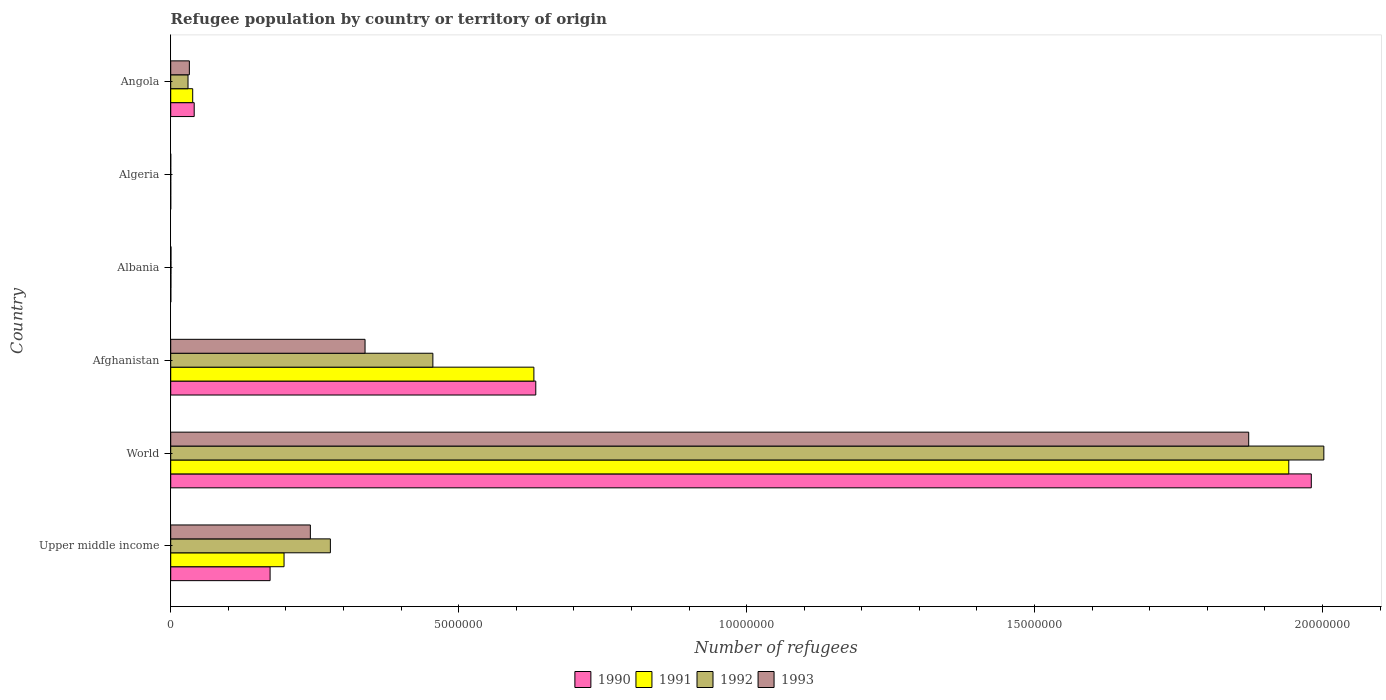How many groups of bars are there?
Give a very brief answer. 6. Are the number of bars on each tick of the Y-axis equal?
Provide a short and direct response. Yes. How many bars are there on the 4th tick from the top?
Keep it short and to the point. 4. How many bars are there on the 2nd tick from the bottom?
Your response must be concise. 4. What is the label of the 1st group of bars from the top?
Your response must be concise. Angola. What is the number of refugees in 1993 in Angola?
Ensure brevity in your answer.  3.24e+05. Across all countries, what is the maximum number of refugees in 1990?
Keep it short and to the point. 1.98e+07. Across all countries, what is the minimum number of refugees in 1992?
Your answer should be compact. 71. In which country was the number of refugees in 1992 maximum?
Provide a succinct answer. World. In which country was the number of refugees in 1993 minimum?
Make the answer very short. Algeria. What is the total number of refugees in 1992 in the graph?
Ensure brevity in your answer.  2.77e+07. What is the difference between the number of refugees in 1991 in Albania and that in World?
Keep it short and to the point. -1.94e+07. What is the difference between the number of refugees in 1990 in Albania and the number of refugees in 1992 in Angola?
Ensure brevity in your answer.  -2.99e+05. What is the average number of refugees in 1990 per country?
Offer a very short reply. 4.71e+06. What is the difference between the number of refugees in 1991 and number of refugees in 1993 in Albania?
Your answer should be compact. -1204. In how many countries, is the number of refugees in 1993 greater than 9000000 ?
Give a very brief answer. 1. What is the ratio of the number of refugees in 1993 in Albania to that in World?
Make the answer very short. 0. What is the difference between the highest and the second highest number of refugees in 1990?
Keep it short and to the point. 1.35e+07. What is the difference between the highest and the lowest number of refugees in 1991?
Ensure brevity in your answer.  1.94e+07. Is the sum of the number of refugees in 1991 in Algeria and Upper middle income greater than the maximum number of refugees in 1992 across all countries?
Keep it short and to the point. No. Is it the case that in every country, the sum of the number of refugees in 1991 and number of refugees in 1993 is greater than the sum of number of refugees in 1990 and number of refugees in 1992?
Provide a short and direct response. No. What does the 1st bar from the top in Upper middle income represents?
Give a very brief answer. 1993. What does the 4th bar from the bottom in Afghanistan represents?
Ensure brevity in your answer.  1993. How many bars are there?
Your response must be concise. 24. How many countries are there in the graph?
Keep it short and to the point. 6. What is the difference between two consecutive major ticks on the X-axis?
Provide a succinct answer. 5.00e+06. Are the values on the major ticks of X-axis written in scientific E-notation?
Give a very brief answer. No. Does the graph contain any zero values?
Ensure brevity in your answer.  No. Where does the legend appear in the graph?
Make the answer very short. Bottom center. How many legend labels are there?
Your answer should be very brief. 4. How are the legend labels stacked?
Offer a terse response. Horizontal. What is the title of the graph?
Provide a short and direct response. Refugee population by country or territory of origin. Does "2007" appear as one of the legend labels in the graph?
Your response must be concise. No. What is the label or title of the X-axis?
Ensure brevity in your answer.  Number of refugees. What is the Number of refugees in 1990 in Upper middle income?
Your answer should be compact. 1.73e+06. What is the Number of refugees in 1991 in Upper middle income?
Give a very brief answer. 1.97e+06. What is the Number of refugees of 1992 in Upper middle income?
Offer a terse response. 2.77e+06. What is the Number of refugees in 1993 in Upper middle income?
Give a very brief answer. 2.42e+06. What is the Number of refugees in 1990 in World?
Offer a very short reply. 1.98e+07. What is the Number of refugees of 1991 in World?
Provide a short and direct response. 1.94e+07. What is the Number of refugees of 1992 in World?
Make the answer very short. 2.00e+07. What is the Number of refugees of 1993 in World?
Make the answer very short. 1.87e+07. What is the Number of refugees in 1990 in Afghanistan?
Keep it short and to the point. 6.34e+06. What is the Number of refugees in 1991 in Afghanistan?
Provide a succinct answer. 6.31e+06. What is the Number of refugees of 1992 in Afghanistan?
Offer a very short reply. 4.55e+06. What is the Number of refugees of 1993 in Afghanistan?
Keep it short and to the point. 3.37e+06. What is the Number of refugees of 1990 in Albania?
Provide a succinct answer. 1822. What is the Number of refugees in 1991 in Albania?
Give a very brief answer. 3540. What is the Number of refugees of 1992 in Albania?
Make the answer very short. 4353. What is the Number of refugees of 1993 in Albania?
Your answer should be very brief. 4744. What is the Number of refugees of 1993 in Algeria?
Your response must be concise. 86. What is the Number of refugees in 1990 in Angola?
Keep it short and to the point. 4.08e+05. What is the Number of refugees of 1991 in Angola?
Make the answer very short. 3.82e+05. What is the Number of refugees of 1992 in Angola?
Provide a short and direct response. 3.00e+05. What is the Number of refugees in 1993 in Angola?
Your response must be concise. 3.24e+05. Across all countries, what is the maximum Number of refugees of 1990?
Your response must be concise. 1.98e+07. Across all countries, what is the maximum Number of refugees of 1991?
Ensure brevity in your answer.  1.94e+07. Across all countries, what is the maximum Number of refugees in 1992?
Keep it short and to the point. 2.00e+07. Across all countries, what is the maximum Number of refugees in 1993?
Your answer should be very brief. 1.87e+07. Across all countries, what is the minimum Number of refugees in 1992?
Offer a very short reply. 71. What is the total Number of refugees in 1990 in the graph?
Your answer should be very brief. 2.83e+07. What is the total Number of refugees of 1991 in the graph?
Provide a succinct answer. 2.81e+07. What is the total Number of refugees in 1992 in the graph?
Provide a short and direct response. 2.77e+07. What is the total Number of refugees of 1993 in the graph?
Provide a short and direct response. 2.48e+07. What is the difference between the Number of refugees of 1990 in Upper middle income and that in World?
Provide a short and direct response. -1.81e+07. What is the difference between the Number of refugees in 1991 in Upper middle income and that in World?
Keep it short and to the point. -1.74e+07. What is the difference between the Number of refugees of 1992 in Upper middle income and that in World?
Ensure brevity in your answer.  -1.73e+07. What is the difference between the Number of refugees in 1993 in Upper middle income and that in World?
Give a very brief answer. -1.63e+07. What is the difference between the Number of refugees in 1990 in Upper middle income and that in Afghanistan?
Give a very brief answer. -4.61e+06. What is the difference between the Number of refugees in 1991 in Upper middle income and that in Afghanistan?
Make the answer very short. -4.34e+06. What is the difference between the Number of refugees in 1992 in Upper middle income and that in Afghanistan?
Offer a terse response. -1.78e+06. What is the difference between the Number of refugees in 1993 in Upper middle income and that in Afghanistan?
Ensure brevity in your answer.  -9.50e+05. What is the difference between the Number of refugees in 1990 in Upper middle income and that in Albania?
Provide a short and direct response. 1.72e+06. What is the difference between the Number of refugees in 1991 in Upper middle income and that in Albania?
Your answer should be very brief. 1.96e+06. What is the difference between the Number of refugees in 1992 in Upper middle income and that in Albania?
Offer a very short reply. 2.77e+06. What is the difference between the Number of refugees in 1993 in Upper middle income and that in Albania?
Provide a short and direct response. 2.42e+06. What is the difference between the Number of refugees of 1990 in Upper middle income and that in Algeria?
Give a very brief answer. 1.73e+06. What is the difference between the Number of refugees in 1991 in Upper middle income and that in Algeria?
Your answer should be compact. 1.97e+06. What is the difference between the Number of refugees in 1992 in Upper middle income and that in Algeria?
Your answer should be very brief. 2.77e+06. What is the difference between the Number of refugees of 1993 in Upper middle income and that in Algeria?
Ensure brevity in your answer.  2.42e+06. What is the difference between the Number of refugees of 1990 in Upper middle income and that in Angola?
Keep it short and to the point. 1.32e+06. What is the difference between the Number of refugees in 1991 in Upper middle income and that in Angola?
Make the answer very short. 1.59e+06. What is the difference between the Number of refugees of 1992 in Upper middle income and that in Angola?
Your response must be concise. 2.47e+06. What is the difference between the Number of refugees of 1993 in Upper middle income and that in Angola?
Your response must be concise. 2.10e+06. What is the difference between the Number of refugees of 1990 in World and that in Afghanistan?
Keep it short and to the point. 1.35e+07. What is the difference between the Number of refugees of 1991 in World and that in Afghanistan?
Ensure brevity in your answer.  1.31e+07. What is the difference between the Number of refugees in 1992 in World and that in Afghanistan?
Your answer should be very brief. 1.55e+07. What is the difference between the Number of refugees of 1993 in World and that in Afghanistan?
Your answer should be very brief. 1.53e+07. What is the difference between the Number of refugees in 1990 in World and that in Albania?
Make the answer very short. 1.98e+07. What is the difference between the Number of refugees of 1991 in World and that in Albania?
Make the answer very short. 1.94e+07. What is the difference between the Number of refugees in 1992 in World and that in Albania?
Your answer should be compact. 2.00e+07. What is the difference between the Number of refugees in 1993 in World and that in Albania?
Provide a short and direct response. 1.87e+07. What is the difference between the Number of refugees of 1990 in World and that in Algeria?
Offer a very short reply. 1.98e+07. What is the difference between the Number of refugees in 1991 in World and that in Algeria?
Provide a short and direct response. 1.94e+07. What is the difference between the Number of refugees of 1992 in World and that in Algeria?
Give a very brief answer. 2.00e+07. What is the difference between the Number of refugees in 1993 in World and that in Algeria?
Give a very brief answer. 1.87e+07. What is the difference between the Number of refugees of 1990 in World and that in Angola?
Provide a succinct answer. 1.94e+07. What is the difference between the Number of refugees in 1991 in World and that in Angola?
Your answer should be very brief. 1.90e+07. What is the difference between the Number of refugees in 1992 in World and that in Angola?
Give a very brief answer. 1.97e+07. What is the difference between the Number of refugees in 1993 in World and that in Angola?
Offer a terse response. 1.84e+07. What is the difference between the Number of refugees in 1990 in Afghanistan and that in Albania?
Ensure brevity in your answer.  6.34e+06. What is the difference between the Number of refugees in 1991 in Afghanistan and that in Albania?
Your answer should be compact. 6.30e+06. What is the difference between the Number of refugees in 1992 in Afghanistan and that in Albania?
Your answer should be very brief. 4.55e+06. What is the difference between the Number of refugees in 1993 in Afghanistan and that in Albania?
Provide a short and direct response. 3.37e+06. What is the difference between the Number of refugees of 1990 in Afghanistan and that in Algeria?
Provide a short and direct response. 6.34e+06. What is the difference between the Number of refugees in 1991 in Afghanistan and that in Algeria?
Provide a short and direct response. 6.31e+06. What is the difference between the Number of refugees of 1992 in Afghanistan and that in Algeria?
Your answer should be very brief. 4.55e+06. What is the difference between the Number of refugees of 1993 in Afghanistan and that in Algeria?
Provide a succinct answer. 3.37e+06. What is the difference between the Number of refugees in 1990 in Afghanistan and that in Angola?
Provide a succinct answer. 5.93e+06. What is the difference between the Number of refugees in 1991 in Afghanistan and that in Angola?
Offer a terse response. 5.92e+06. What is the difference between the Number of refugees in 1992 in Afghanistan and that in Angola?
Offer a terse response. 4.25e+06. What is the difference between the Number of refugees of 1993 in Afghanistan and that in Angola?
Provide a short and direct response. 3.05e+06. What is the difference between the Number of refugees of 1990 in Albania and that in Algeria?
Offer a very short reply. 1803. What is the difference between the Number of refugees of 1991 in Albania and that in Algeria?
Your answer should be very brief. 3485. What is the difference between the Number of refugees in 1992 in Albania and that in Algeria?
Ensure brevity in your answer.  4282. What is the difference between the Number of refugees in 1993 in Albania and that in Algeria?
Keep it short and to the point. 4658. What is the difference between the Number of refugees of 1990 in Albania and that in Angola?
Ensure brevity in your answer.  -4.06e+05. What is the difference between the Number of refugees of 1991 in Albania and that in Angola?
Make the answer very short. -3.78e+05. What is the difference between the Number of refugees of 1992 in Albania and that in Angola?
Make the answer very short. -2.96e+05. What is the difference between the Number of refugees of 1993 in Albania and that in Angola?
Ensure brevity in your answer.  -3.19e+05. What is the difference between the Number of refugees of 1990 in Algeria and that in Angola?
Offer a terse response. -4.08e+05. What is the difference between the Number of refugees in 1991 in Algeria and that in Angola?
Your answer should be very brief. -3.82e+05. What is the difference between the Number of refugees of 1992 in Algeria and that in Angola?
Provide a succinct answer. -3.00e+05. What is the difference between the Number of refugees of 1993 in Algeria and that in Angola?
Provide a short and direct response. -3.24e+05. What is the difference between the Number of refugees of 1990 in Upper middle income and the Number of refugees of 1991 in World?
Your answer should be very brief. -1.77e+07. What is the difference between the Number of refugees of 1990 in Upper middle income and the Number of refugees of 1992 in World?
Offer a terse response. -1.83e+07. What is the difference between the Number of refugees in 1990 in Upper middle income and the Number of refugees in 1993 in World?
Provide a short and direct response. -1.70e+07. What is the difference between the Number of refugees of 1991 in Upper middle income and the Number of refugees of 1992 in World?
Provide a short and direct response. -1.81e+07. What is the difference between the Number of refugees of 1991 in Upper middle income and the Number of refugees of 1993 in World?
Your response must be concise. -1.68e+07. What is the difference between the Number of refugees in 1992 in Upper middle income and the Number of refugees in 1993 in World?
Ensure brevity in your answer.  -1.59e+07. What is the difference between the Number of refugees of 1990 in Upper middle income and the Number of refugees of 1991 in Afghanistan?
Ensure brevity in your answer.  -4.58e+06. What is the difference between the Number of refugees of 1990 in Upper middle income and the Number of refugees of 1992 in Afghanistan?
Give a very brief answer. -2.83e+06. What is the difference between the Number of refugees in 1990 in Upper middle income and the Number of refugees in 1993 in Afghanistan?
Offer a terse response. -1.65e+06. What is the difference between the Number of refugees of 1991 in Upper middle income and the Number of refugees of 1992 in Afghanistan?
Make the answer very short. -2.58e+06. What is the difference between the Number of refugees of 1991 in Upper middle income and the Number of refugees of 1993 in Afghanistan?
Offer a terse response. -1.41e+06. What is the difference between the Number of refugees of 1992 in Upper middle income and the Number of refugees of 1993 in Afghanistan?
Ensure brevity in your answer.  -6.02e+05. What is the difference between the Number of refugees of 1990 in Upper middle income and the Number of refugees of 1991 in Albania?
Keep it short and to the point. 1.72e+06. What is the difference between the Number of refugees of 1990 in Upper middle income and the Number of refugees of 1992 in Albania?
Provide a succinct answer. 1.72e+06. What is the difference between the Number of refugees of 1990 in Upper middle income and the Number of refugees of 1993 in Albania?
Your answer should be compact. 1.72e+06. What is the difference between the Number of refugees in 1991 in Upper middle income and the Number of refugees in 1992 in Albania?
Provide a succinct answer. 1.96e+06. What is the difference between the Number of refugees of 1991 in Upper middle income and the Number of refugees of 1993 in Albania?
Make the answer very short. 1.96e+06. What is the difference between the Number of refugees in 1992 in Upper middle income and the Number of refugees in 1993 in Albania?
Keep it short and to the point. 2.77e+06. What is the difference between the Number of refugees in 1990 in Upper middle income and the Number of refugees in 1991 in Algeria?
Your answer should be very brief. 1.73e+06. What is the difference between the Number of refugees in 1990 in Upper middle income and the Number of refugees in 1992 in Algeria?
Your answer should be very brief. 1.73e+06. What is the difference between the Number of refugees of 1990 in Upper middle income and the Number of refugees of 1993 in Algeria?
Make the answer very short. 1.73e+06. What is the difference between the Number of refugees of 1991 in Upper middle income and the Number of refugees of 1992 in Algeria?
Provide a short and direct response. 1.97e+06. What is the difference between the Number of refugees of 1991 in Upper middle income and the Number of refugees of 1993 in Algeria?
Provide a succinct answer. 1.97e+06. What is the difference between the Number of refugees in 1992 in Upper middle income and the Number of refugees in 1993 in Algeria?
Provide a succinct answer. 2.77e+06. What is the difference between the Number of refugees in 1990 in Upper middle income and the Number of refugees in 1991 in Angola?
Offer a terse response. 1.34e+06. What is the difference between the Number of refugees in 1990 in Upper middle income and the Number of refugees in 1992 in Angola?
Your answer should be compact. 1.43e+06. What is the difference between the Number of refugees in 1990 in Upper middle income and the Number of refugees in 1993 in Angola?
Your answer should be very brief. 1.40e+06. What is the difference between the Number of refugees of 1991 in Upper middle income and the Number of refugees of 1992 in Angola?
Provide a succinct answer. 1.67e+06. What is the difference between the Number of refugees in 1991 in Upper middle income and the Number of refugees in 1993 in Angola?
Give a very brief answer. 1.64e+06. What is the difference between the Number of refugees of 1992 in Upper middle income and the Number of refugees of 1993 in Angola?
Offer a very short reply. 2.45e+06. What is the difference between the Number of refugees of 1990 in World and the Number of refugees of 1991 in Afghanistan?
Provide a short and direct response. 1.35e+07. What is the difference between the Number of refugees of 1990 in World and the Number of refugees of 1992 in Afghanistan?
Give a very brief answer. 1.53e+07. What is the difference between the Number of refugees of 1990 in World and the Number of refugees of 1993 in Afghanistan?
Your response must be concise. 1.64e+07. What is the difference between the Number of refugees of 1991 in World and the Number of refugees of 1992 in Afghanistan?
Your answer should be compact. 1.49e+07. What is the difference between the Number of refugees in 1991 in World and the Number of refugees in 1993 in Afghanistan?
Ensure brevity in your answer.  1.60e+07. What is the difference between the Number of refugees of 1992 in World and the Number of refugees of 1993 in Afghanistan?
Keep it short and to the point. 1.66e+07. What is the difference between the Number of refugees in 1990 in World and the Number of refugees in 1991 in Albania?
Provide a succinct answer. 1.98e+07. What is the difference between the Number of refugees in 1990 in World and the Number of refugees in 1992 in Albania?
Your answer should be compact. 1.98e+07. What is the difference between the Number of refugees in 1990 in World and the Number of refugees in 1993 in Albania?
Ensure brevity in your answer.  1.98e+07. What is the difference between the Number of refugees in 1991 in World and the Number of refugees in 1992 in Albania?
Offer a very short reply. 1.94e+07. What is the difference between the Number of refugees of 1991 in World and the Number of refugees of 1993 in Albania?
Provide a succinct answer. 1.94e+07. What is the difference between the Number of refugees of 1992 in World and the Number of refugees of 1993 in Albania?
Your answer should be compact. 2.00e+07. What is the difference between the Number of refugees of 1990 in World and the Number of refugees of 1991 in Algeria?
Keep it short and to the point. 1.98e+07. What is the difference between the Number of refugees in 1990 in World and the Number of refugees in 1992 in Algeria?
Provide a short and direct response. 1.98e+07. What is the difference between the Number of refugees of 1990 in World and the Number of refugees of 1993 in Algeria?
Provide a succinct answer. 1.98e+07. What is the difference between the Number of refugees of 1991 in World and the Number of refugees of 1992 in Algeria?
Keep it short and to the point. 1.94e+07. What is the difference between the Number of refugees of 1991 in World and the Number of refugees of 1993 in Algeria?
Your response must be concise. 1.94e+07. What is the difference between the Number of refugees of 1992 in World and the Number of refugees of 1993 in Algeria?
Provide a short and direct response. 2.00e+07. What is the difference between the Number of refugees of 1990 in World and the Number of refugees of 1991 in Angola?
Your answer should be compact. 1.94e+07. What is the difference between the Number of refugees in 1990 in World and the Number of refugees in 1992 in Angola?
Your answer should be compact. 1.95e+07. What is the difference between the Number of refugees of 1990 in World and the Number of refugees of 1993 in Angola?
Your answer should be compact. 1.95e+07. What is the difference between the Number of refugees in 1991 in World and the Number of refugees in 1992 in Angola?
Your answer should be compact. 1.91e+07. What is the difference between the Number of refugees of 1991 in World and the Number of refugees of 1993 in Angola?
Give a very brief answer. 1.91e+07. What is the difference between the Number of refugees of 1992 in World and the Number of refugees of 1993 in Angola?
Ensure brevity in your answer.  1.97e+07. What is the difference between the Number of refugees in 1990 in Afghanistan and the Number of refugees in 1991 in Albania?
Ensure brevity in your answer.  6.34e+06. What is the difference between the Number of refugees of 1990 in Afghanistan and the Number of refugees of 1992 in Albania?
Keep it short and to the point. 6.33e+06. What is the difference between the Number of refugees in 1990 in Afghanistan and the Number of refugees in 1993 in Albania?
Offer a terse response. 6.33e+06. What is the difference between the Number of refugees of 1991 in Afghanistan and the Number of refugees of 1992 in Albania?
Your answer should be compact. 6.30e+06. What is the difference between the Number of refugees in 1991 in Afghanistan and the Number of refugees in 1993 in Albania?
Give a very brief answer. 6.30e+06. What is the difference between the Number of refugees of 1992 in Afghanistan and the Number of refugees of 1993 in Albania?
Your answer should be compact. 4.55e+06. What is the difference between the Number of refugees in 1990 in Afghanistan and the Number of refugees in 1991 in Algeria?
Provide a short and direct response. 6.34e+06. What is the difference between the Number of refugees in 1990 in Afghanistan and the Number of refugees in 1992 in Algeria?
Offer a terse response. 6.34e+06. What is the difference between the Number of refugees of 1990 in Afghanistan and the Number of refugees of 1993 in Algeria?
Keep it short and to the point. 6.34e+06. What is the difference between the Number of refugees in 1991 in Afghanistan and the Number of refugees in 1992 in Algeria?
Ensure brevity in your answer.  6.31e+06. What is the difference between the Number of refugees in 1991 in Afghanistan and the Number of refugees in 1993 in Algeria?
Ensure brevity in your answer.  6.31e+06. What is the difference between the Number of refugees in 1992 in Afghanistan and the Number of refugees in 1993 in Algeria?
Provide a succinct answer. 4.55e+06. What is the difference between the Number of refugees of 1990 in Afghanistan and the Number of refugees of 1991 in Angola?
Offer a very short reply. 5.96e+06. What is the difference between the Number of refugees in 1990 in Afghanistan and the Number of refugees in 1992 in Angola?
Provide a short and direct response. 6.04e+06. What is the difference between the Number of refugees of 1990 in Afghanistan and the Number of refugees of 1993 in Angola?
Your answer should be very brief. 6.02e+06. What is the difference between the Number of refugees of 1991 in Afghanistan and the Number of refugees of 1992 in Angola?
Give a very brief answer. 6.01e+06. What is the difference between the Number of refugees of 1991 in Afghanistan and the Number of refugees of 1993 in Angola?
Offer a terse response. 5.98e+06. What is the difference between the Number of refugees of 1992 in Afghanistan and the Number of refugees of 1993 in Angola?
Your answer should be very brief. 4.23e+06. What is the difference between the Number of refugees of 1990 in Albania and the Number of refugees of 1991 in Algeria?
Keep it short and to the point. 1767. What is the difference between the Number of refugees in 1990 in Albania and the Number of refugees in 1992 in Algeria?
Provide a short and direct response. 1751. What is the difference between the Number of refugees in 1990 in Albania and the Number of refugees in 1993 in Algeria?
Give a very brief answer. 1736. What is the difference between the Number of refugees of 1991 in Albania and the Number of refugees of 1992 in Algeria?
Provide a short and direct response. 3469. What is the difference between the Number of refugees in 1991 in Albania and the Number of refugees in 1993 in Algeria?
Your answer should be very brief. 3454. What is the difference between the Number of refugees of 1992 in Albania and the Number of refugees of 1993 in Algeria?
Your answer should be very brief. 4267. What is the difference between the Number of refugees of 1990 in Albania and the Number of refugees of 1991 in Angola?
Provide a short and direct response. -3.80e+05. What is the difference between the Number of refugees in 1990 in Albania and the Number of refugees in 1992 in Angola?
Give a very brief answer. -2.99e+05. What is the difference between the Number of refugees of 1990 in Albania and the Number of refugees of 1993 in Angola?
Offer a terse response. -3.22e+05. What is the difference between the Number of refugees of 1991 in Albania and the Number of refugees of 1992 in Angola?
Ensure brevity in your answer.  -2.97e+05. What is the difference between the Number of refugees in 1991 in Albania and the Number of refugees in 1993 in Angola?
Make the answer very short. -3.20e+05. What is the difference between the Number of refugees in 1992 in Albania and the Number of refugees in 1993 in Angola?
Your response must be concise. -3.19e+05. What is the difference between the Number of refugees in 1990 in Algeria and the Number of refugees in 1991 in Angola?
Your answer should be compact. -3.82e+05. What is the difference between the Number of refugees of 1990 in Algeria and the Number of refugees of 1992 in Angola?
Your answer should be compact. -3.00e+05. What is the difference between the Number of refugees in 1990 in Algeria and the Number of refugees in 1993 in Angola?
Your answer should be very brief. -3.24e+05. What is the difference between the Number of refugees of 1991 in Algeria and the Number of refugees of 1992 in Angola?
Make the answer very short. -3.00e+05. What is the difference between the Number of refugees of 1991 in Algeria and the Number of refugees of 1993 in Angola?
Offer a terse response. -3.24e+05. What is the difference between the Number of refugees in 1992 in Algeria and the Number of refugees in 1993 in Angola?
Your response must be concise. -3.24e+05. What is the average Number of refugees in 1990 per country?
Offer a terse response. 4.71e+06. What is the average Number of refugees in 1991 per country?
Provide a succinct answer. 4.68e+06. What is the average Number of refugees of 1992 per country?
Your answer should be very brief. 4.61e+06. What is the average Number of refugees in 1993 per country?
Ensure brevity in your answer.  4.14e+06. What is the difference between the Number of refugees of 1990 and Number of refugees of 1991 in Upper middle income?
Your response must be concise. -2.42e+05. What is the difference between the Number of refugees in 1990 and Number of refugees in 1992 in Upper middle income?
Your answer should be very brief. -1.05e+06. What is the difference between the Number of refugees of 1990 and Number of refugees of 1993 in Upper middle income?
Make the answer very short. -6.99e+05. What is the difference between the Number of refugees of 1991 and Number of refugees of 1992 in Upper middle income?
Your answer should be compact. -8.04e+05. What is the difference between the Number of refugees in 1991 and Number of refugees in 1993 in Upper middle income?
Offer a very short reply. -4.57e+05. What is the difference between the Number of refugees in 1992 and Number of refugees in 1993 in Upper middle income?
Give a very brief answer. 3.48e+05. What is the difference between the Number of refugees of 1990 and Number of refugees of 1991 in World?
Keep it short and to the point. 3.91e+05. What is the difference between the Number of refugees of 1990 and Number of refugees of 1992 in World?
Provide a succinct answer. -2.18e+05. What is the difference between the Number of refugees of 1990 and Number of refugees of 1993 in World?
Provide a short and direct response. 1.09e+06. What is the difference between the Number of refugees of 1991 and Number of refugees of 1992 in World?
Your response must be concise. -6.09e+05. What is the difference between the Number of refugees of 1991 and Number of refugees of 1993 in World?
Offer a very short reply. 6.96e+05. What is the difference between the Number of refugees in 1992 and Number of refugees in 1993 in World?
Your answer should be compact. 1.30e+06. What is the difference between the Number of refugees in 1990 and Number of refugees in 1991 in Afghanistan?
Your answer should be compact. 3.28e+04. What is the difference between the Number of refugees in 1990 and Number of refugees in 1992 in Afghanistan?
Keep it short and to the point. 1.79e+06. What is the difference between the Number of refugees of 1990 and Number of refugees of 1993 in Afghanistan?
Give a very brief answer. 2.96e+06. What is the difference between the Number of refugees of 1991 and Number of refugees of 1992 in Afghanistan?
Ensure brevity in your answer.  1.75e+06. What is the difference between the Number of refugees of 1991 and Number of refugees of 1993 in Afghanistan?
Provide a short and direct response. 2.93e+06. What is the difference between the Number of refugees in 1992 and Number of refugees in 1993 in Afghanistan?
Provide a short and direct response. 1.18e+06. What is the difference between the Number of refugees of 1990 and Number of refugees of 1991 in Albania?
Provide a short and direct response. -1718. What is the difference between the Number of refugees in 1990 and Number of refugees in 1992 in Albania?
Ensure brevity in your answer.  -2531. What is the difference between the Number of refugees of 1990 and Number of refugees of 1993 in Albania?
Ensure brevity in your answer.  -2922. What is the difference between the Number of refugees of 1991 and Number of refugees of 1992 in Albania?
Make the answer very short. -813. What is the difference between the Number of refugees of 1991 and Number of refugees of 1993 in Albania?
Make the answer very short. -1204. What is the difference between the Number of refugees in 1992 and Number of refugees in 1993 in Albania?
Provide a succinct answer. -391. What is the difference between the Number of refugees in 1990 and Number of refugees in 1991 in Algeria?
Offer a very short reply. -36. What is the difference between the Number of refugees of 1990 and Number of refugees of 1992 in Algeria?
Your response must be concise. -52. What is the difference between the Number of refugees in 1990 and Number of refugees in 1993 in Algeria?
Your answer should be very brief. -67. What is the difference between the Number of refugees of 1991 and Number of refugees of 1993 in Algeria?
Your answer should be very brief. -31. What is the difference between the Number of refugees of 1992 and Number of refugees of 1993 in Algeria?
Your answer should be compact. -15. What is the difference between the Number of refugees of 1990 and Number of refugees of 1991 in Angola?
Provide a succinct answer. 2.61e+04. What is the difference between the Number of refugees in 1990 and Number of refugees in 1992 in Angola?
Give a very brief answer. 1.07e+05. What is the difference between the Number of refugees in 1990 and Number of refugees in 1993 in Angola?
Ensure brevity in your answer.  8.39e+04. What is the difference between the Number of refugees in 1991 and Number of refugees in 1992 in Angola?
Make the answer very short. 8.11e+04. What is the difference between the Number of refugees of 1991 and Number of refugees of 1993 in Angola?
Offer a terse response. 5.78e+04. What is the difference between the Number of refugees in 1992 and Number of refugees in 1993 in Angola?
Offer a terse response. -2.33e+04. What is the ratio of the Number of refugees of 1990 in Upper middle income to that in World?
Keep it short and to the point. 0.09. What is the ratio of the Number of refugees of 1991 in Upper middle income to that in World?
Make the answer very short. 0.1. What is the ratio of the Number of refugees of 1992 in Upper middle income to that in World?
Provide a succinct answer. 0.14. What is the ratio of the Number of refugees of 1993 in Upper middle income to that in World?
Offer a terse response. 0.13. What is the ratio of the Number of refugees of 1990 in Upper middle income to that in Afghanistan?
Keep it short and to the point. 0.27. What is the ratio of the Number of refugees in 1991 in Upper middle income to that in Afghanistan?
Give a very brief answer. 0.31. What is the ratio of the Number of refugees in 1992 in Upper middle income to that in Afghanistan?
Ensure brevity in your answer.  0.61. What is the ratio of the Number of refugees of 1993 in Upper middle income to that in Afghanistan?
Offer a very short reply. 0.72. What is the ratio of the Number of refugees in 1990 in Upper middle income to that in Albania?
Keep it short and to the point. 947.17. What is the ratio of the Number of refugees of 1991 in Upper middle income to that in Albania?
Offer a terse response. 555.95. What is the ratio of the Number of refugees of 1992 in Upper middle income to that in Albania?
Offer a very short reply. 636.92. What is the ratio of the Number of refugees of 1993 in Upper middle income to that in Albania?
Provide a succinct answer. 511.15. What is the ratio of the Number of refugees of 1990 in Upper middle income to that in Algeria?
Give a very brief answer. 9.08e+04. What is the ratio of the Number of refugees in 1991 in Upper middle income to that in Algeria?
Offer a very short reply. 3.58e+04. What is the ratio of the Number of refugees of 1992 in Upper middle income to that in Algeria?
Your response must be concise. 3.90e+04. What is the ratio of the Number of refugees of 1993 in Upper middle income to that in Algeria?
Keep it short and to the point. 2.82e+04. What is the ratio of the Number of refugees in 1990 in Upper middle income to that in Angola?
Ensure brevity in your answer.  4.23. What is the ratio of the Number of refugees in 1991 in Upper middle income to that in Angola?
Provide a short and direct response. 5.16. What is the ratio of the Number of refugees in 1992 in Upper middle income to that in Angola?
Your response must be concise. 9.23. What is the ratio of the Number of refugees in 1993 in Upper middle income to that in Angola?
Give a very brief answer. 7.49. What is the ratio of the Number of refugees in 1990 in World to that in Afghanistan?
Your answer should be very brief. 3.12. What is the ratio of the Number of refugees of 1991 in World to that in Afghanistan?
Your response must be concise. 3.08. What is the ratio of the Number of refugees in 1992 in World to that in Afghanistan?
Offer a terse response. 4.4. What is the ratio of the Number of refugees in 1993 in World to that in Afghanistan?
Ensure brevity in your answer.  5.55. What is the ratio of the Number of refugees of 1990 in World to that in Albania?
Offer a terse response. 1.09e+04. What is the ratio of the Number of refugees of 1991 in World to that in Albania?
Ensure brevity in your answer.  5484.44. What is the ratio of the Number of refugees of 1992 in World to that in Albania?
Offer a very short reply. 4599.94. What is the ratio of the Number of refugees of 1993 in World to that in Albania?
Keep it short and to the point. 3945.82. What is the ratio of the Number of refugees of 1990 in World to that in Algeria?
Keep it short and to the point. 1.04e+06. What is the ratio of the Number of refugees of 1991 in World to that in Algeria?
Ensure brevity in your answer.  3.53e+05. What is the ratio of the Number of refugees in 1992 in World to that in Algeria?
Make the answer very short. 2.82e+05. What is the ratio of the Number of refugees of 1993 in World to that in Algeria?
Your answer should be very brief. 2.18e+05. What is the ratio of the Number of refugees in 1990 in World to that in Angola?
Ensure brevity in your answer.  48.57. What is the ratio of the Number of refugees of 1991 in World to that in Angola?
Your response must be concise. 50.87. What is the ratio of the Number of refugees in 1992 in World to that in Angola?
Your response must be concise. 66.64. What is the ratio of the Number of refugees in 1993 in World to that in Angola?
Make the answer very short. 57.8. What is the ratio of the Number of refugees of 1990 in Afghanistan to that in Albania?
Your answer should be compact. 3479.2. What is the ratio of the Number of refugees of 1991 in Afghanistan to that in Albania?
Ensure brevity in your answer.  1781.44. What is the ratio of the Number of refugees of 1992 in Afghanistan to that in Albania?
Ensure brevity in your answer.  1045.75. What is the ratio of the Number of refugees of 1993 in Afghanistan to that in Albania?
Keep it short and to the point. 711.34. What is the ratio of the Number of refugees in 1990 in Afghanistan to that in Algeria?
Provide a succinct answer. 3.34e+05. What is the ratio of the Number of refugees of 1991 in Afghanistan to that in Algeria?
Keep it short and to the point. 1.15e+05. What is the ratio of the Number of refugees of 1992 in Afghanistan to that in Algeria?
Provide a short and direct response. 6.41e+04. What is the ratio of the Number of refugees in 1993 in Afghanistan to that in Algeria?
Your answer should be compact. 3.92e+04. What is the ratio of the Number of refugees of 1990 in Afghanistan to that in Angola?
Ensure brevity in your answer.  15.55. What is the ratio of the Number of refugees of 1991 in Afghanistan to that in Angola?
Your response must be concise. 16.52. What is the ratio of the Number of refugees in 1992 in Afghanistan to that in Angola?
Keep it short and to the point. 15.15. What is the ratio of the Number of refugees of 1993 in Afghanistan to that in Angola?
Provide a short and direct response. 10.42. What is the ratio of the Number of refugees of 1990 in Albania to that in Algeria?
Provide a succinct answer. 95.89. What is the ratio of the Number of refugees in 1991 in Albania to that in Algeria?
Provide a succinct answer. 64.36. What is the ratio of the Number of refugees of 1992 in Albania to that in Algeria?
Offer a terse response. 61.31. What is the ratio of the Number of refugees of 1993 in Albania to that in Algeria?
Offer a terse response. 55.16. What is the ratio of the Number of refugees in 1990 in Albania to that in Angola?
Provide a short and direct response. 0. What is the ratio of the Number of refugees of 1991 in Albania to that in Angola?
Your response must be concise. 0.01. What is the ratio of the Number of refugees of 1992 in Albania to that in Angola?
Ensure brevity in your answer.  0.01. What is the ratio of the Number of refugees of 1993 in Albania to that in Angola?
Your answer should be very brief. 0.01. What is the ratio of the Number of refugees in 1990 in Algeria to that in Angola?
Provide a succinct answer. 0. What is the difference between the highest and the second highest Number of refugees in 1990?
Keep it short and to the point. 1.35e+07. What is the difference between the highest and the second highest Number of refugees in 1991?
Provide a succinct answer. 1.31e+07. What is the difference between the highest and the second highest Number of refugees of 1992?
Ensure brevity in your answer.  1.55e+07. What is the difference between the highest and the second highest Number of refugees in 1993?
Keep it short and to the point. 1.53e+07. What is the difference between the highest and the lowest Number of refugees in 1990?
Ensure brevity in your answer.  1.98e+07. What is the difference between the highest and the lowest Number of refugees of 1991?
Provide a succinct answer. 1.94e+07. What is the difference between the highest and the lowest Number of refugees of 1992?
Your answer should be very brief. 2.00e+07. What is the difference between the highest and the lowest Number of refugees in 1993?
Provide a succinct answer. 1.87e+07. 